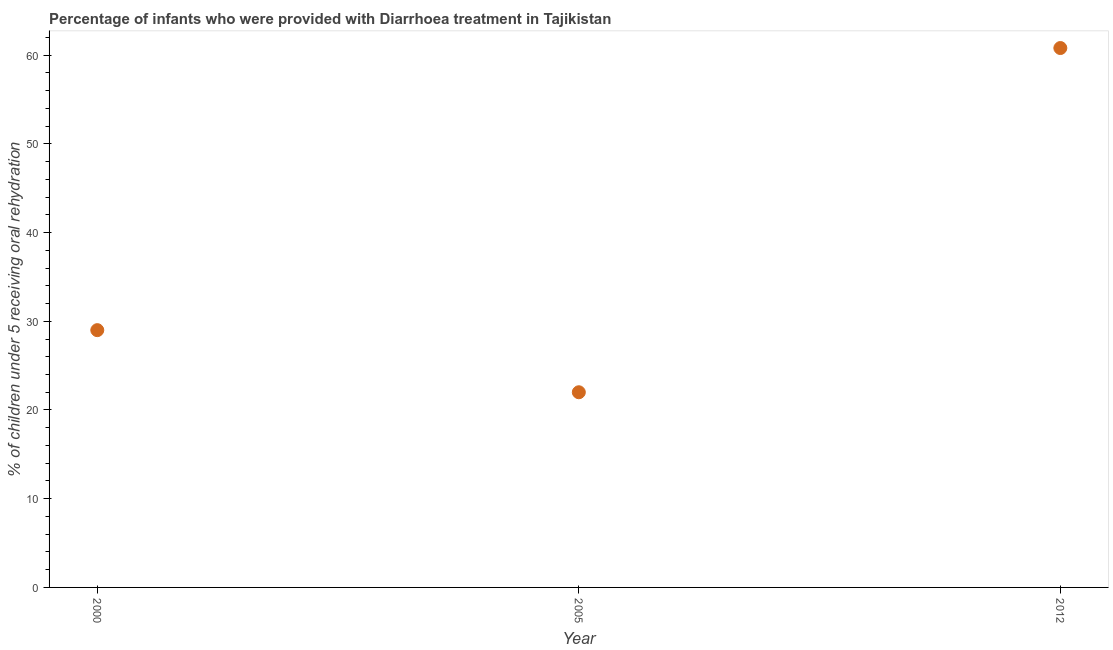What is the percentage of children who were provided with treatment diarrhoea in 2005?
Your answer should be very brief. 22. Across all years, what is the maximum percentage of children who were provided with treatment diarrhoea?
Ensure brevity in your answer.  60.8. In which year was the percentage of children who were provided with treatment diarrhoea minimum?
Your answer should be compact. 2005. What is the sum of the percentage of children who were provided with treatment diarrhoea?
Provide a short and direct response. 111.8. What is the difference between the percentage of children who were provided with treatment diarrhoea in 2000 and 2012?
Ensure brevity in your answer.  -31.8. What is the average percentage of children who were provided with treatment diarrhoea per year?
Your answer should be very brief. 37.27. In how many years, is the percentage of children who were provided with treatment diarrhoea greater than 30 %?
Make the answer very short. 1. Do a majority of the years between 2012 and 2000 (inclusive) have percentage of children who were provided with treatment diarrhoea greater than 50 %?
Your answer should be compact. No. What is the ratio of the percentage of children who were provided with treatment diarrhoea in 2000 to that in 2005?
Provide a short and direct response. 1.32. Is the difference between the percentage of children who were provided with treatment diarrhoea in 2005 and 2012 greater than the difference between any two years?
Your response must be concise. Yes. What is the difference between the highest and the second highest percentage of children who were provided with treatment diarrhoea?
Keep it short and to the point. 31.8. What is the difference between the highest and the lowest percentage of children who were provided with treatment diarrhoea?
Offer a very short reply. 38.8. Does the percentage of children who were provided with treatment diarrhoea monotonically increase over the years?
Provide a short and direct response. No. How many dotlines are there?
Make the answer very short. 1. Does the graph contain any zero values?
Your response must be concise. No. What is the title of the graph?
Provide a succinct answer. Percentage of infants who were provided with Diarrhoea treatment in Tajikistan. What is the label or title of the Y-axis?
Give a very brief answer. % of children under 5 receiving oral rehydration. What is the % of children under 5 receiving oral rehydration in 2000?
Give a very brief answer. 29. What is the % of children under 5 receiving oral rehydration in 2012?
Ensure brevity in your answer.  60.8. What is the difference between the % of children under 5 receiving oral rehydration in 2000 and 2012?
Your response must be concise. -31.8. What is the difference between the % of children under 5 receiving oral rehydration in 2005 and 2012?
Provide a short and direct response. -38.8. What is the ratio of the % of children under 5 receiving oral rehydration in 2000 to that in 2005?
Offer a terse response. 1.32. What is the ratio of the % of children under 5 receiving oral rehydration in 2000 to that in 2012?
Keep it short and to the point. 0.48. What is the ratio of the % of children under 5 receiving oral rehydration in 2005 to that in 2012?
Ensure brevity in your answer.  0.36. 